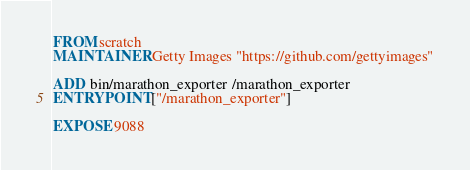Convert code to text. <code><loc_0><loc_0><loc_500><loc_500><_Dockerfile_>FROM scratch
MAINTAINER Getty Images "https://github.com/gettyimages"

ADD bin/marathon_exporter /marathon_exporter
ENTRYPOINT ["/marathon_exporter"]

EXPOSE 9088
</code> 